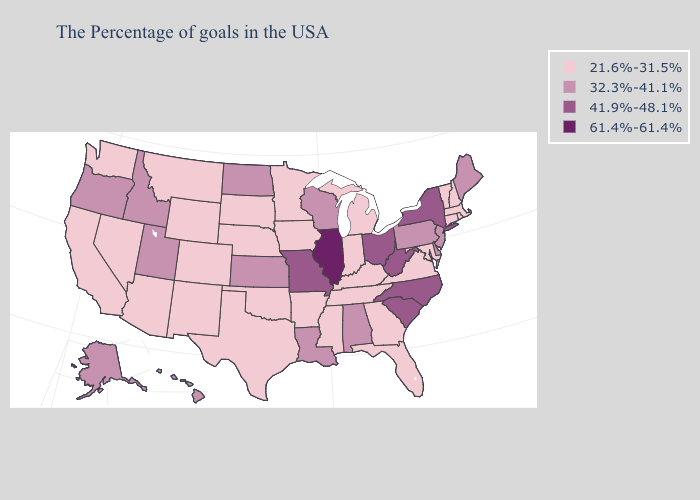Does Louisiana have the lowest value in the USA?
Be succinct. No. Name the states that have a value in the range 61.4%-61.4%?
Be succinct. Illinois. Does Utah have the lowest value in the USA?
Keep it brief. No. What is the value of Arkansas?
Write a very short answer. 21.6%-31.5%. Does California have a higher value than Illinois?
Answer briefly. No. Name the states that have a value in the range 32.3%-41.1%?
Quick response, please. Maine, New Jersey, Delaware, Pennsylvania, Alabama, Wisconsin, Louisiana, Kansas, North Dakota, Utah, Idaho, Oregon, Alaska, Hawaii. What is the highest value in the USA?
Short answer required. 61.4%-61.4%. Name the states that have a value in the range 41.9%-48.1%?
Keep it brief. New York, North Carolina, South Carolina, West Virginia, Ohio, Missouri. What is the lowest value in the USA?
Write a very short answer. 21.6%-31.5%. Name the states that have a value in the range 21.6%-31.5%?
Concise answer only. Massachusetts, Rhode Island, New Hampshire, Vermont, Connecticut, Maryland, Virginia, Florida, Georgia, Michigan, Kentucky, Indiana, Tennessee, Mississippi, Arkansas, Minnesota, Iowa, Nebraska, Oklahoma, Texas, South Dakota, Wyoming, Colorado, New Mexico, Montana, Arizona, Nevada, California, Washington. Does Nevada have the lowest value in the USA?
Be succinct. Yes. What is the lowest value in the Northeast?
Be succinct. 21.6%-31.5%. Name the states that have a value in the range 21.6%-31.5%?
Keep it brief. Massachusetts, Rhode Island, New Hampshire, Vermont, Connecticut, Maryland, Virginia, Florida, Georgia, Michigan, Kentucky, Indiana, Tennessee, Mississippi, Arkansas, Minnesota, Iowa, Nebraska, Oklahoma, Texas, South Dakota, Wyoming, Colorado, New Mexico, Montana, Arizona, Nevada, California, Washington. Is the legend a continuous bar?
Short answer required. No. Does Mississippi have a lower value than North Dakota?
Keep it brief. Yes. 